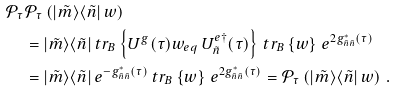<formula> <loc_0><loc_0><loc_500><loc_500>\mathcal { P } _ { \tau } & \mathcal { P } _ { \tau } \left ( | \tilde { m } \rangle \langle \tilde { n } | \, w \right ) \\ & = | \tilde { m } \rangle \langle \tilde { n } | \, t r _ { B } \left \{ U ^ { g } ( \tau ) w _ { e q } \, U _ { \tilde { n } } ^ { e \dagger } ( \tau ) \right \} \, t r _ { B } \left \{ w \right \} \, e ^ { 2 g _ { \tilde { n } \tilde { n } } ^ { * } ( \tau ) } \\ & = | \tilde { m } \rangle \langle \tilde { n } | \, e ^ { - g _ { \tilde { n } \tilde { n } } ^ { * } ( \tau ) } \, t r _ { B } \left \{ w \right \} \, e ^ { 2 g _ { \tilde { n } \tilde { n } } ^ { * } ( \tau ) } = \mathcal { P } _ { \tau } \left ( | \tilde { m } \rangle \langle \tilde { n } | \, w \right ) \, .</formula> 